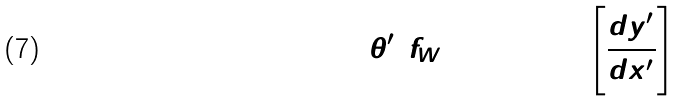Convert formula to latex. <formula><loc_0><loc_0><loc_500><loc_500>\theta ^ { \prime } ( f _ { W } ) = \arctan \left [ \frac { d y _ { 2 } ^ { \prime } } { d x _ { 2 } ^ { \prime } } \right ]</formula> 